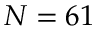Convert formula to latex. <formula><loc_0><loc_0><loc_500><loc_500>N = 6 1</formula> 